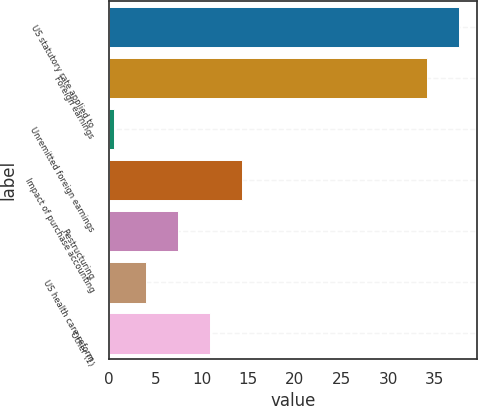<chart> <loc_0><loc_0><loc_500><loc_500><bar_chart><fcel>US statutory rate applied to<fcel>Foreign earnings<fcel>Unremitted foreign earnings<fcel>Impact of purchase accounting<fcel>Restructuring<fcel>US health care reform<fcel>Other (1)<nl><fcel>37.64<fcel>34.2<fcel>0.6<fcel>14.36<fcel>7.48<fcel>4.04<fcel>10.92<nl></chart> 